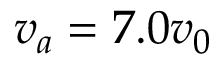<formula> <loc_0><loc_0><loc_500><loc_500>v _ { a } = 7 . 0 v _ { 0 }</formula> 